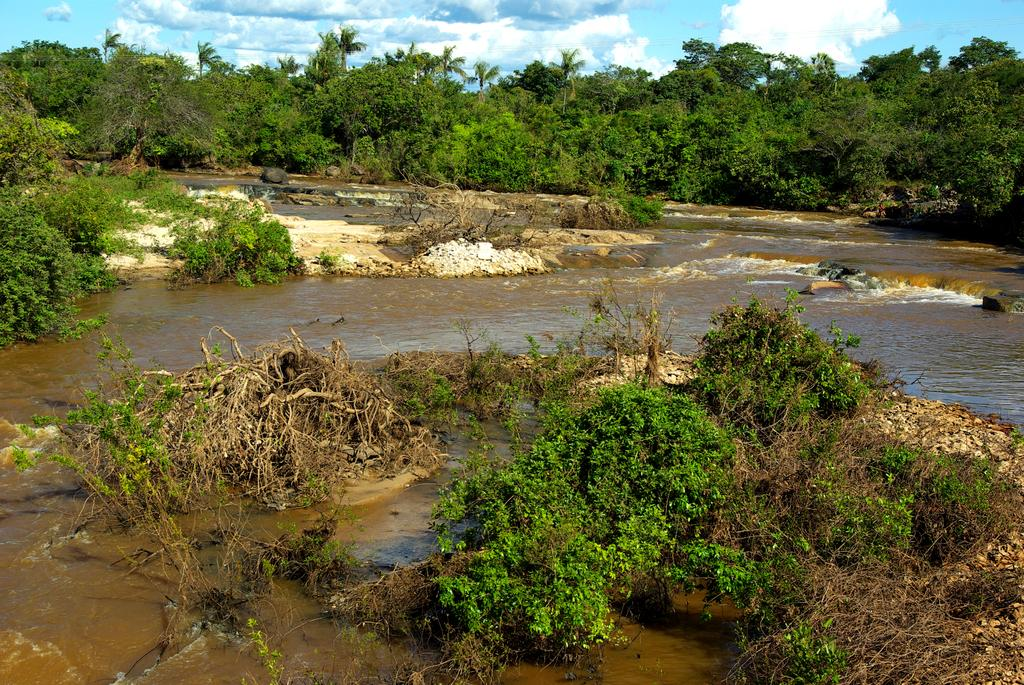What is the primary element visible in the image? There is water in the image. What can be seen on the ground in the image? There are plants on the ground in the image. What is visible in the background of the image? There are trees and clouds in the sky in the background of the image. What type of pancake is being cooked in the wilderness in the image? There is no pancake or wilderness present in the image; it features water, plants, trees, and clouds. 